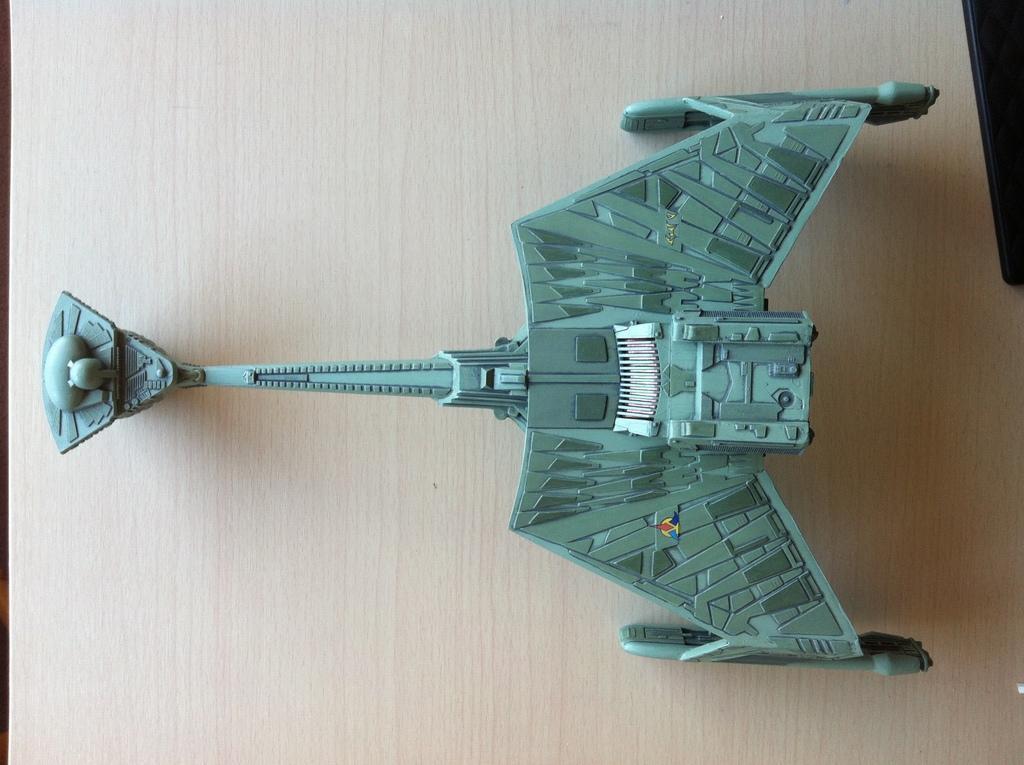Could you give a brief overview of what you see in this image? Here I can see a metal object which is looking like a toy and it is placed on a table. In the top right I can see a black color object. 